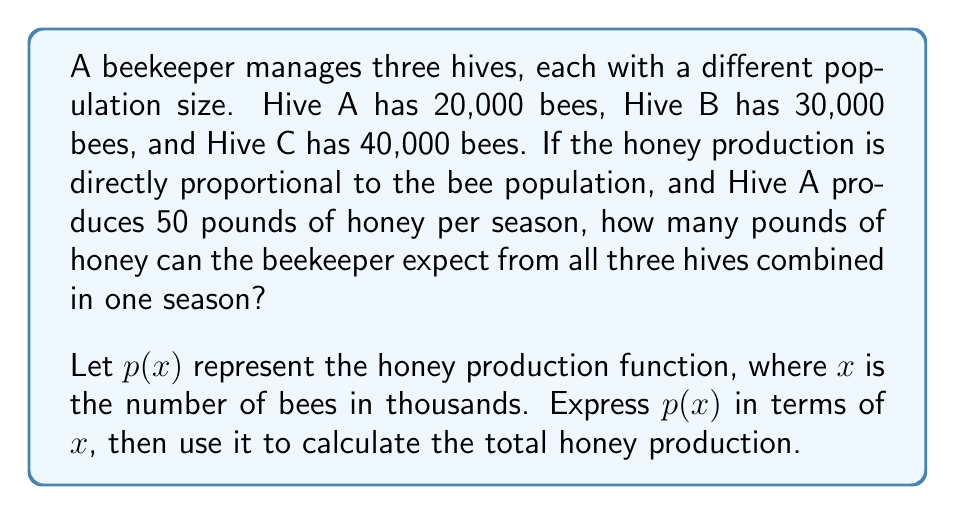Solve this math problem. To solve this problem, we need to follow these steps:

1. Determine the honey production function $p(x)$.
2. Calculate the honey production for each hive.
3. Sum up the production from all three hives.

Step 1: Determining $p(x)$

We know that Hive A, with 20,000 bees, produces 50 pounds of honey. Let's express this as an equation:

$p(20) = 50$

Since the honey production is directly proportional to the bee population, we can express $p(x)$ as:

$p(x) = kx$

where $k$ is the constant of proportionality. We can find $k$ using the given information:

$50 = k(20)$
$k = \frac{50}{20} = 2.5$

Therefore, the honey production function is:

$p(x) = 2.5x$

Step 2: Calculating honey production for each hive

Hive A: $p(20) = 2.5(20) = 50$ pounds
Hive B: $p(30) = 2.5(30) = 75$ pounds
Hive C: $p(40) = 2.5(40) = 100$ pounds

Step 3: Summing up the production from all three hives

Total honey production = Hive A + Hive B + Hive C
$= 50 + 75 + 100 = 225$ pounds

Therefore, the beekeeper can expect 225 pounds of honey from all three hives combined in one season.
Answer: 225 pounds of honey 